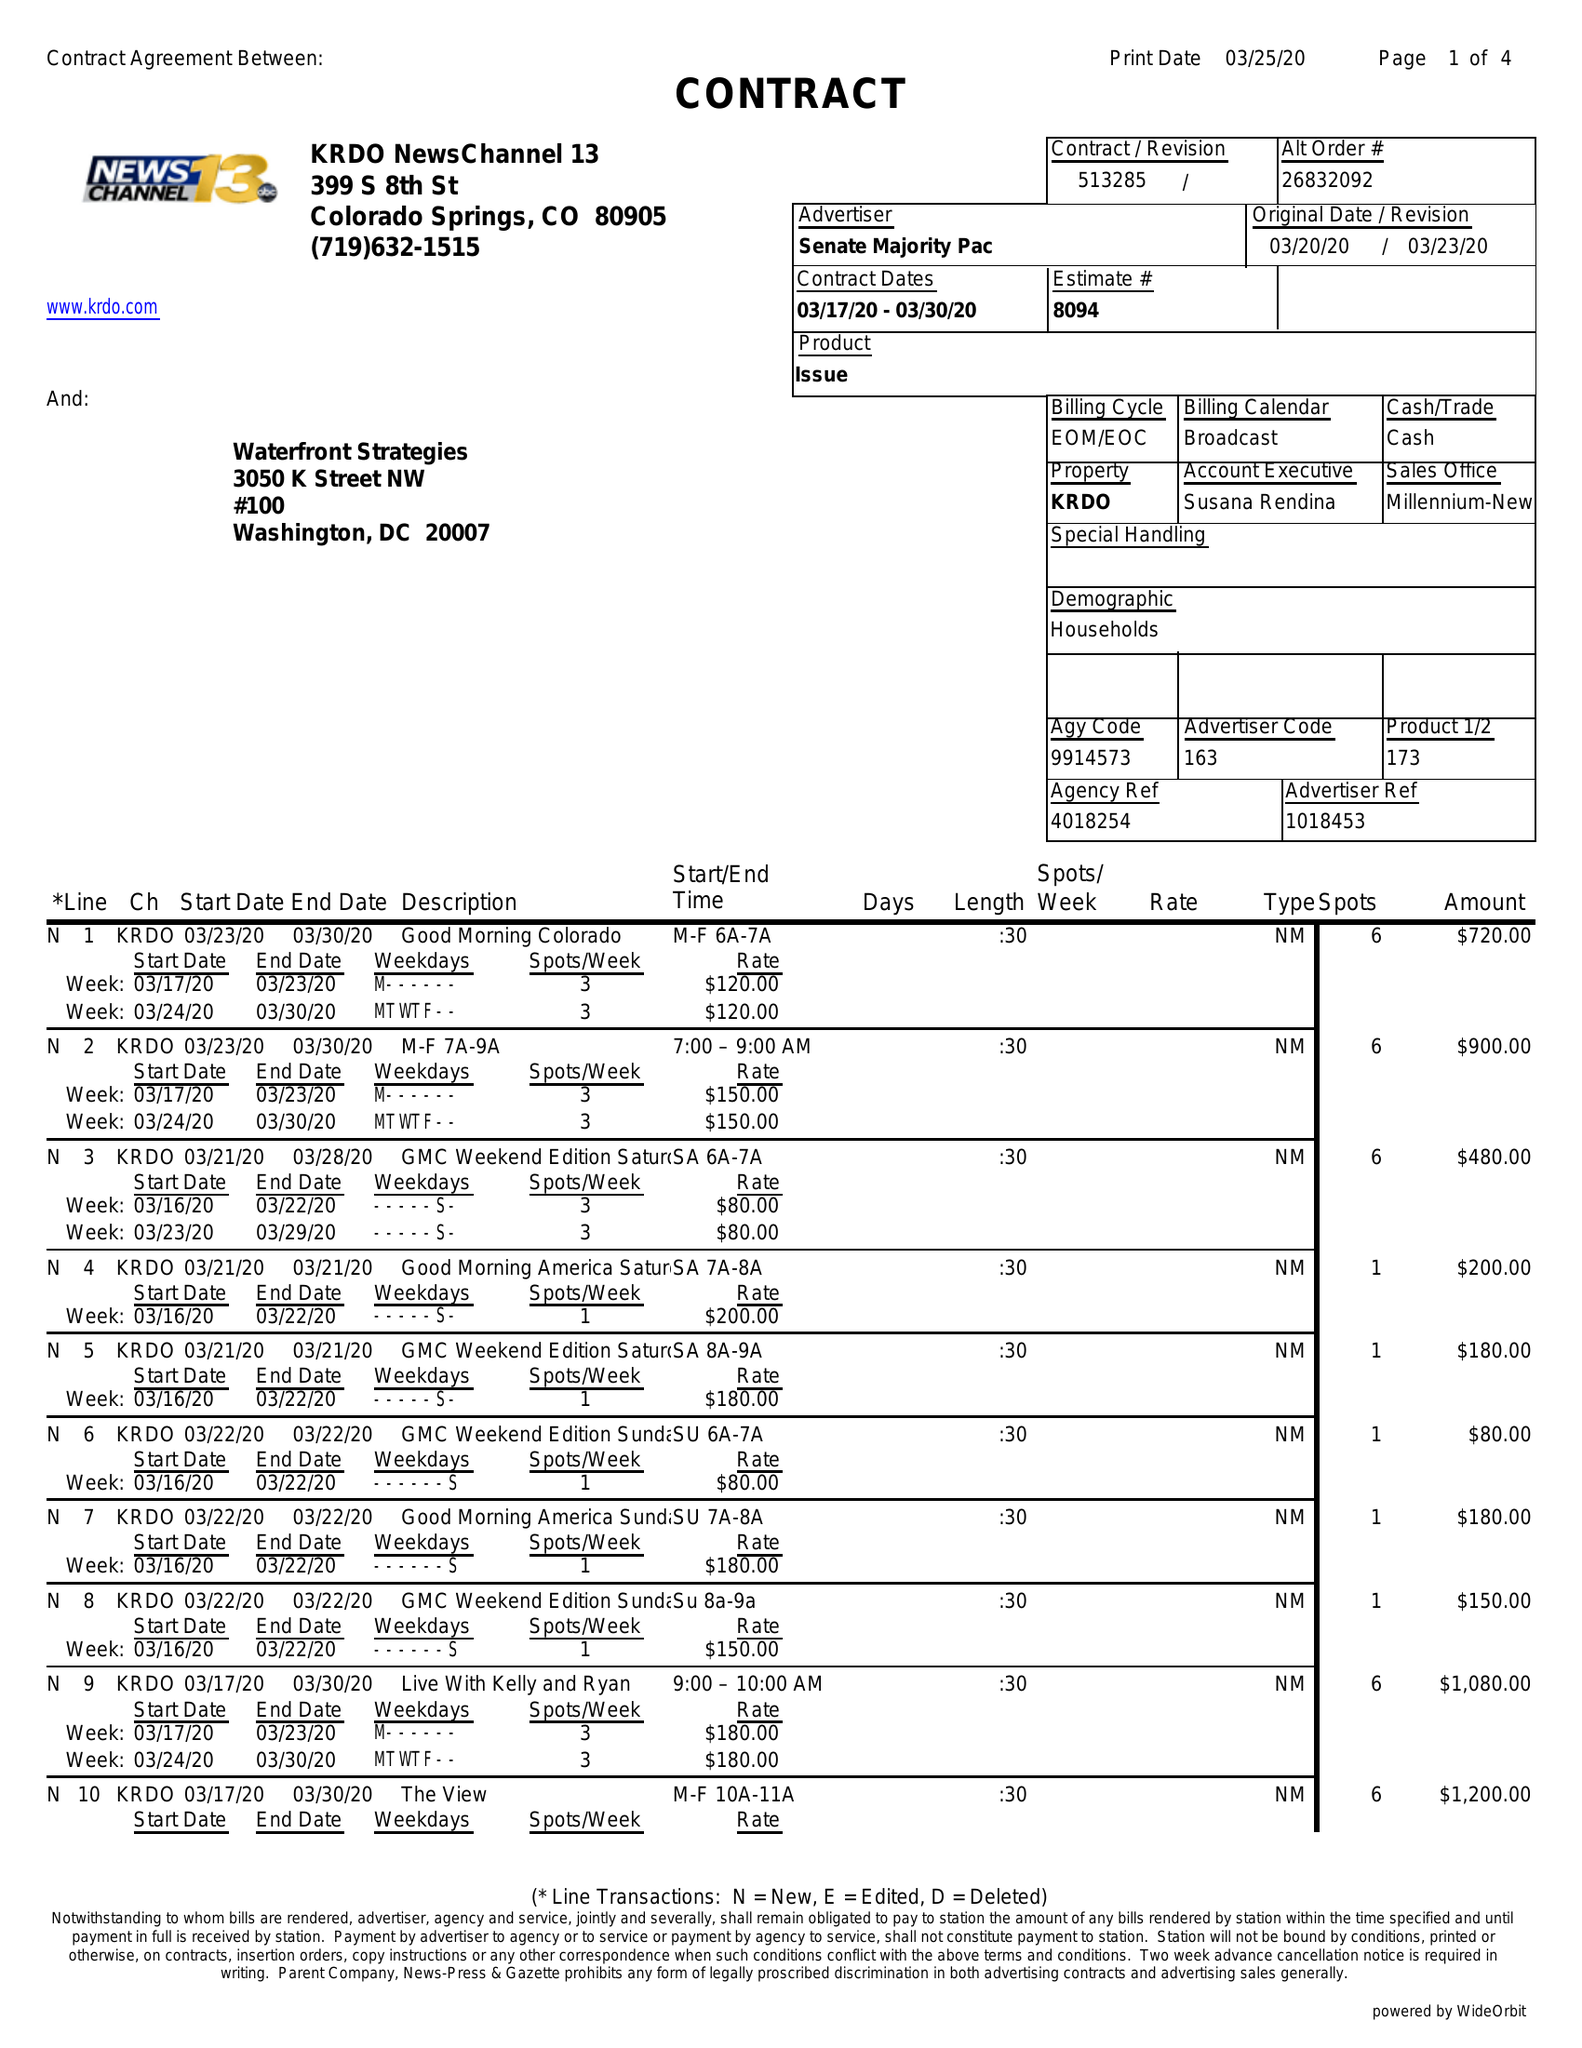What is the value for the gross_amount?
Answer the question using a single word or phrase. 26855.00 